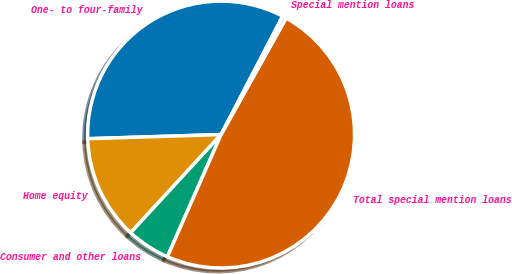Convert chart. <chart><loc_0><loc_0><loc_500><loc_500><pie_chart><fcel>One- to four-family<fcel>Home equity<fcel>Consumer and other loans<fcel>Total special mention loans<fcel>Special mention loans<nl><fcel>33.13%<fcel>12.65%<fcel>5.26%<fcel>48.49%<fcel>0.46%<nl></chart> 